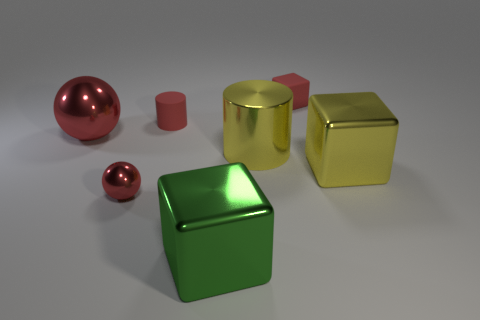Subtract all big metal blocks. How many blocks are left? 1 Add 1 small matte cylinders. How many objects exist? 8 Subtract all yellow cubes. How many cubes are left? 2 Subtract 2 cubes. How many cubes are left? 1 Subtract all cylinders. How many objects are left? 5 Subtract all gray cubes. Subtract all yellow balls. How many cubes are left? 3 Subtract all yellow cylinders. How many green cubes are left? 1 Subtract all metal cylinders. Subtract all red matte objects. How many objects are left? 4 Add 5 metal cylinders. How many metal cylinders are left? 6 Add 6 big yellow cylinders. How many big yellow cylinders exist? 7 